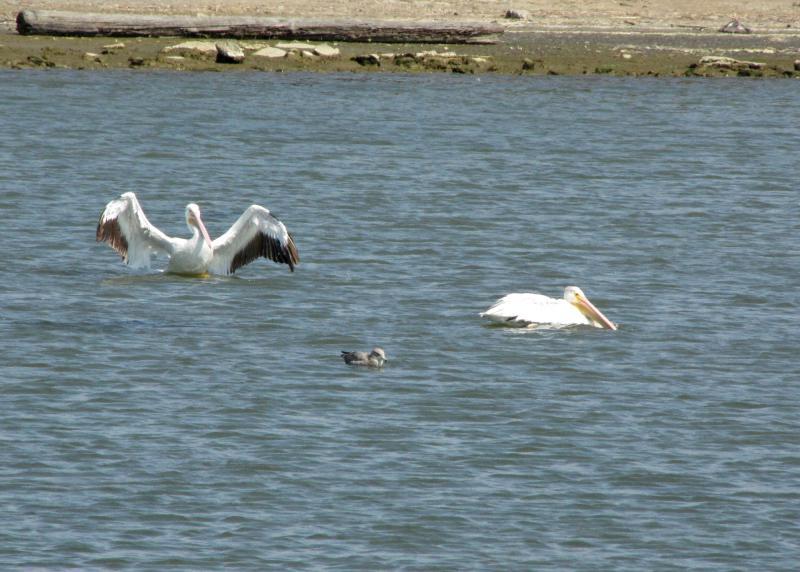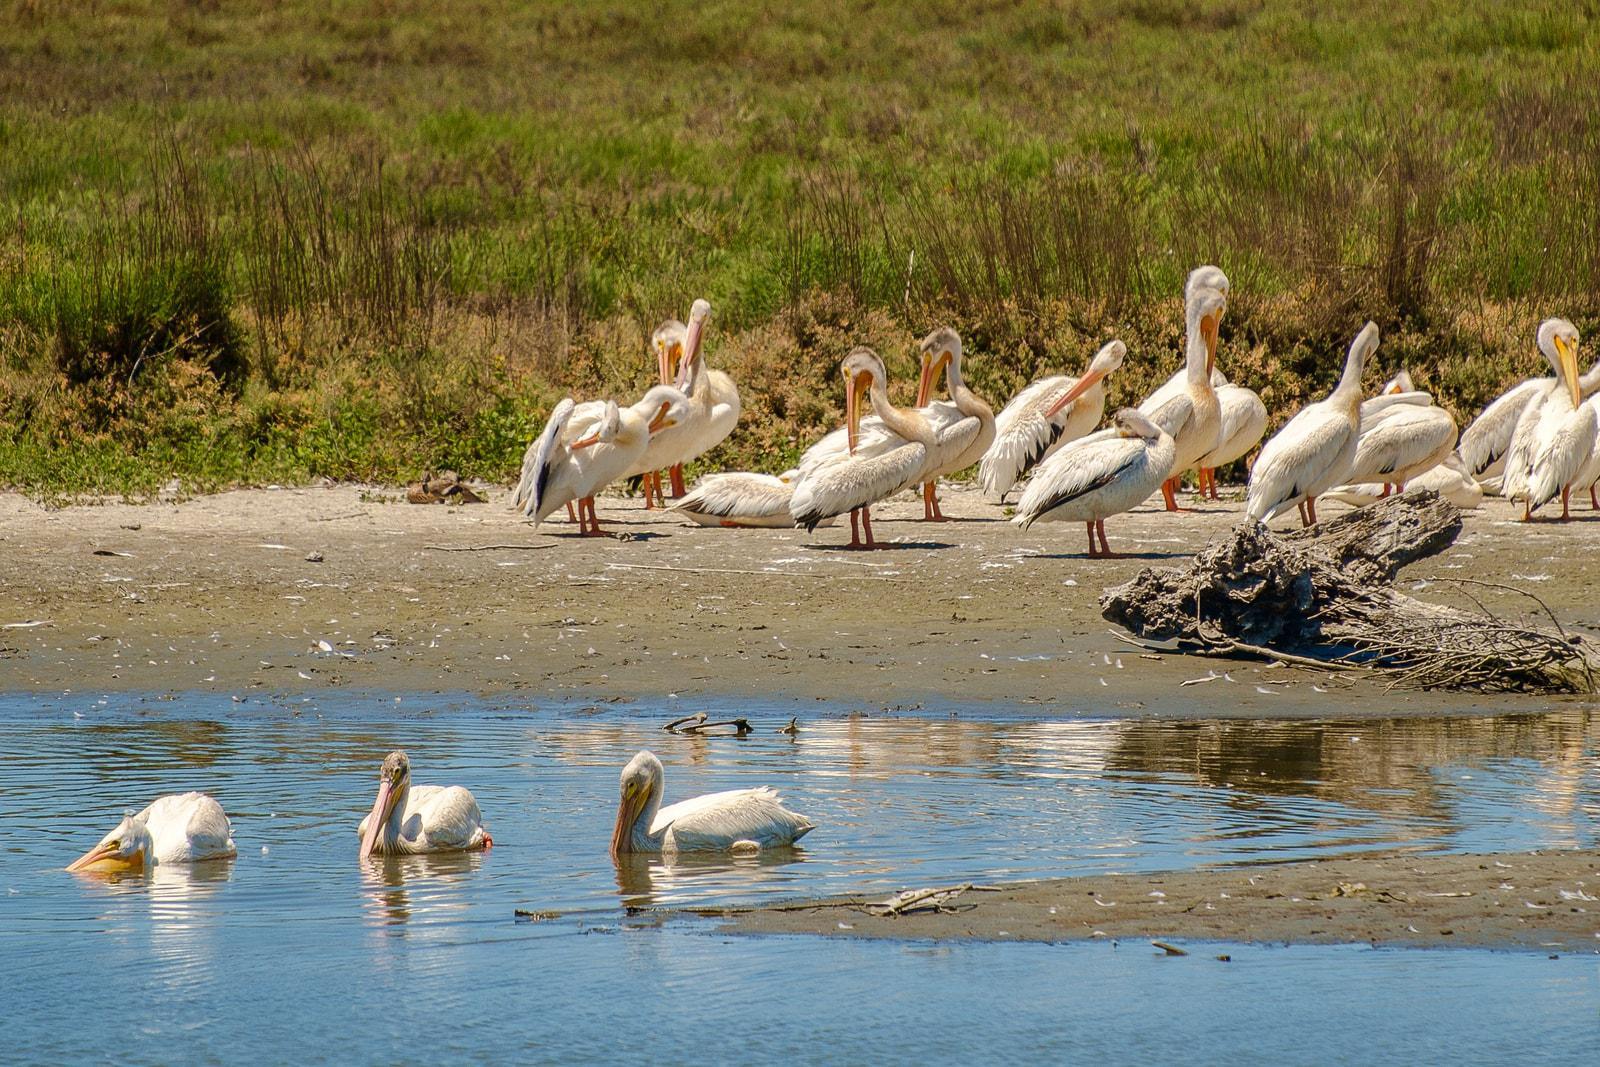The first image is the image on the left, the second image is the image on the right. For the images displayed, is the sentence "One lone pelican is out of the water in one of the images, while all of the pelicans are swimming in the other image." factually correct? Answer yes or no. No. 